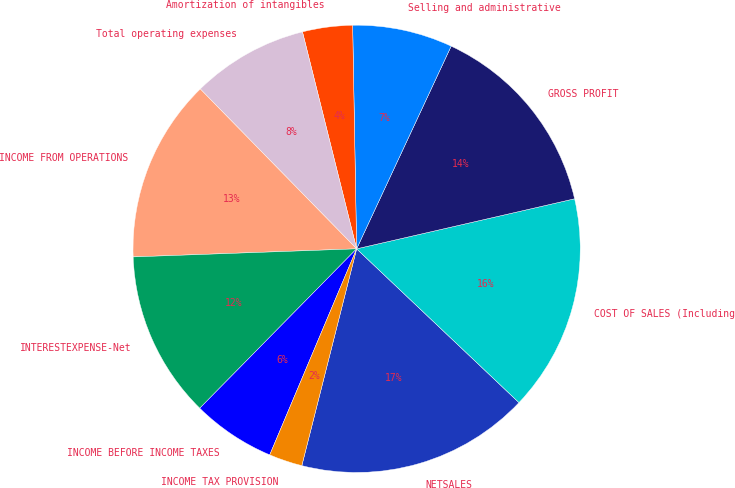Convert chart to OTSL. <chart><loc_0><loc_0><loc_500><loc_500><pie_chart><fcel>NETSALES<fcel>COST OF SALES (Including<fcel>GROSS PROFIT<fcel>Selling and administrative<fcel>Amortization of intangibles<fcel>Total operating expenses<fcel>INCOME FROM OPERATIONS<fcel>INTERESTEXPENSE-Net<fcel>INCOME BEFORE INCOME TAXES<fcel>INCOME TAX PROVISION<nl><fcel>16.87%<fcel>15.66%<fcel>14.46%<fcel>7.23%<fcel>3.61%<fcel>8.43%<fcel>13.25%<fcel>12.05%<fcel>6.02%<fcel>2.41%<nl></chart> 